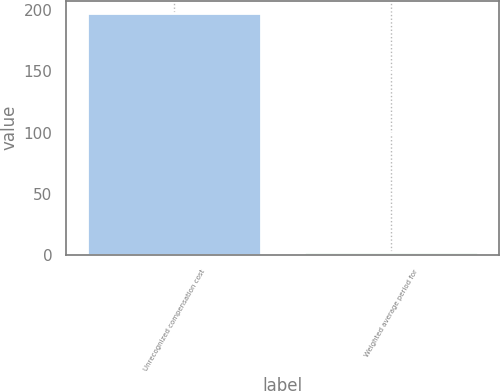Convert chart to OTSL. <chart><loc_0><loc_0><loc_500><loc_500><bar_chart><fcel>Unrecognized compensation cost<fcel>Weighted average period for<nl><fcel>198<fcel>2.5<nl></chart> 